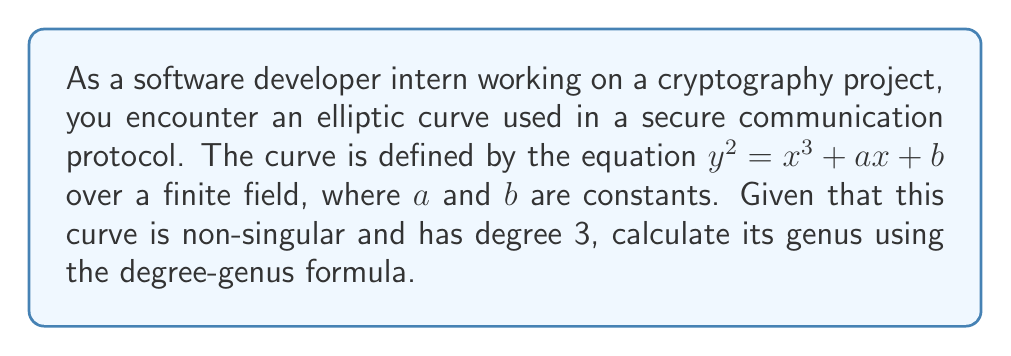Help me with this question. Let's approach this step-by-step:

1) The degree-genus formula for a non-singular plane curve is:

   $$g = \frac{(d-1)(d-2)}{2}$$

   where $g$ is the genus and $d$ is the degree of the curve.

2) We are given that the curve is an elliptic curve defined by $y^2 = x^3 + ax + b$.

3) To find the degree, we need to consider the highest degree term. In this case, it's $x^3$, so the degree $d = 3$.

4) Now, let's substitute $d = 3$ into the formula:

   $$g = \frac{(3-1)(3-2)}{2}$$

5) Simplify:
   $$g = \frac{(2)(1)}{2} = 1$$

6) Therefore, the genus of the elliptic curve is 1.

This result is consistent with the fact that all non-singular elliptic curves have genus 1, which is a key property that makes them useful in cryptography.
Answer: 1 